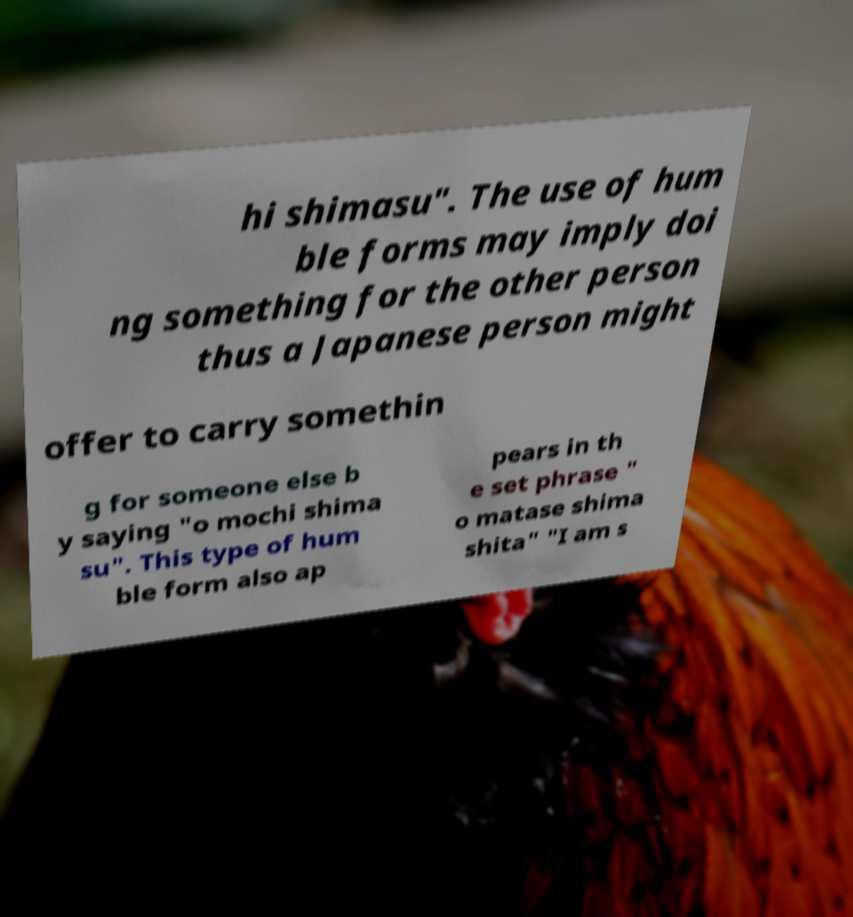Please read and relay the text visible in this image. What does it say? hi shimasu". The use of hum ble forms may imply doi ng something for the other person thus a Japanese person might offer to carry somethin g for someone else b y saying "o mochi shima su". This type of hum ble form also ap pears in th e set phrase " o matase shima shita" "I am s 